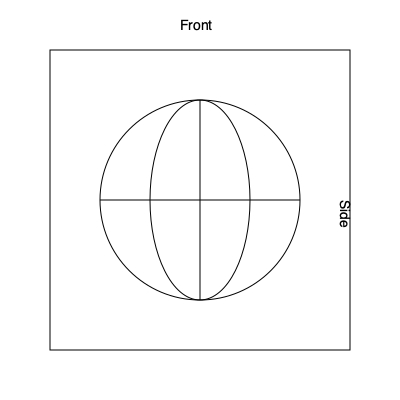Based on the given diagram representing different views of a DJ speaker, which of the following rotations would result in the side view becoming the front view?
A) 90° clockwise around the vertical axis
B) 90° counterclockwise around the vertical axis
C) 180° around the horizontal axis
D) No rotation needed To solve this problem, let's analyze the given diagram and the speaker's geometry:

1. The diagram shows two views of a DJ speaker: front view and side view.
2. The front view is represented by a circle, indicating that the speaker is round when viewed from the front.
3. The side view is represented by an ellipse, showing that the speaker has depth and is not flat.

To determine which rotation would make the side view become the front view:

1. Option A (90° clockwise around the vertical axis):
   - This would rotate the speaker so that the current side becomes the back, and the current front becomes the side.
   - This is not correct, as we want the side to become the front.

2. Option B (90° counterclockwise around the vertical axis):
   - This would rotate the speaker so that the current side becomes the front, and the current front becomes the side.
   - This is the correct rotation to achieve the desired result.

3. Option C (180° around the horizontal axis):
   - This would flip the speaker upside down, but the front and side views would remain unchanged.
   - This is not correct.

4. Option D (No rotation needed):
   - This is clearly incorrect, as the side view is different from the front view and requires rotation to become the front view.

Therefore, the correct answer is option B: 90° counterclockwise around the vertical axis.
Answer: B) 90° counterclockwise around the vertical axis 